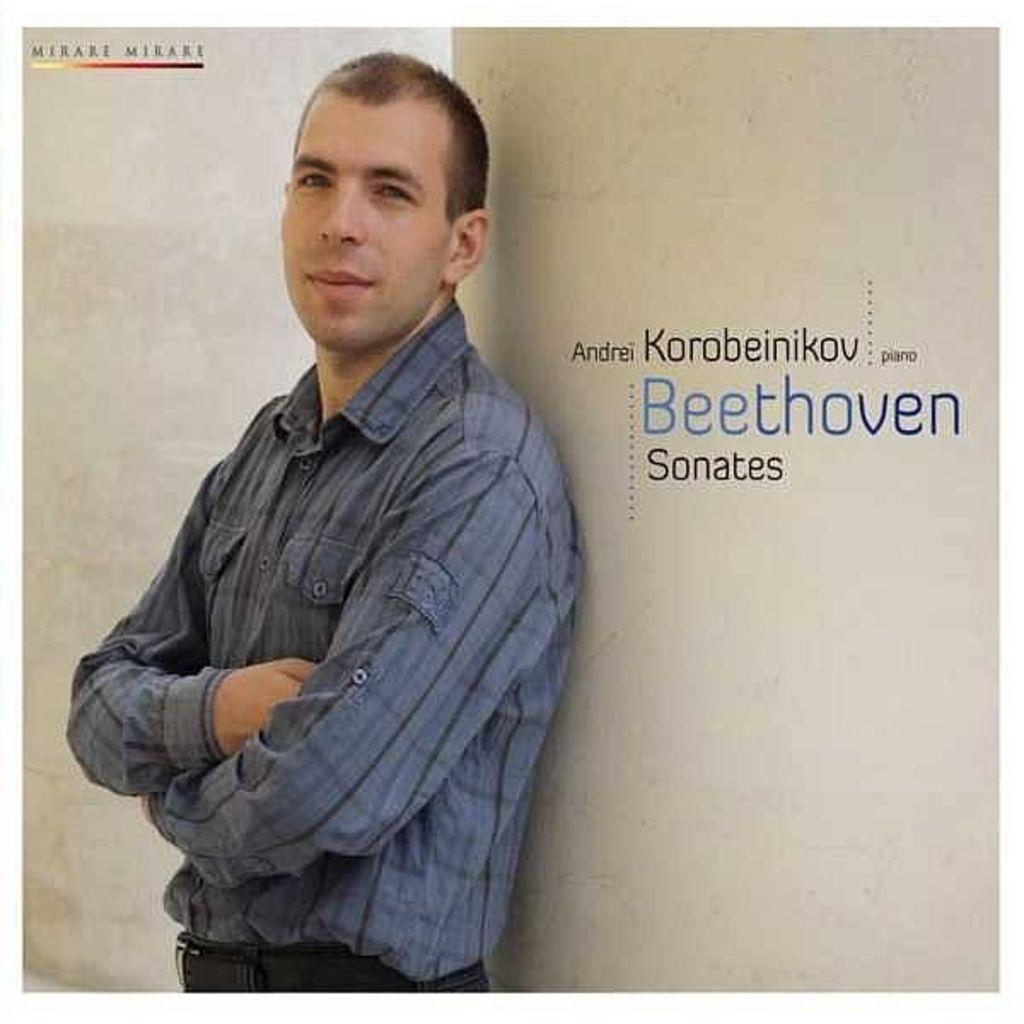What is the main subject of the image? There is a person in the image. What can be seen in the background of the image? There is a wall in the image. Are there any details on the wall? Yes, there is some text on the wall. Can you describe any other features on the wall? There is a watermark on the wall. How many chickens are visible in the image? There are no chickens present in the image. What type of disease is mentioned in the text on the wall? The image does not provide any information about diseases; it only shows a person, a wall, text, and a watermark. 